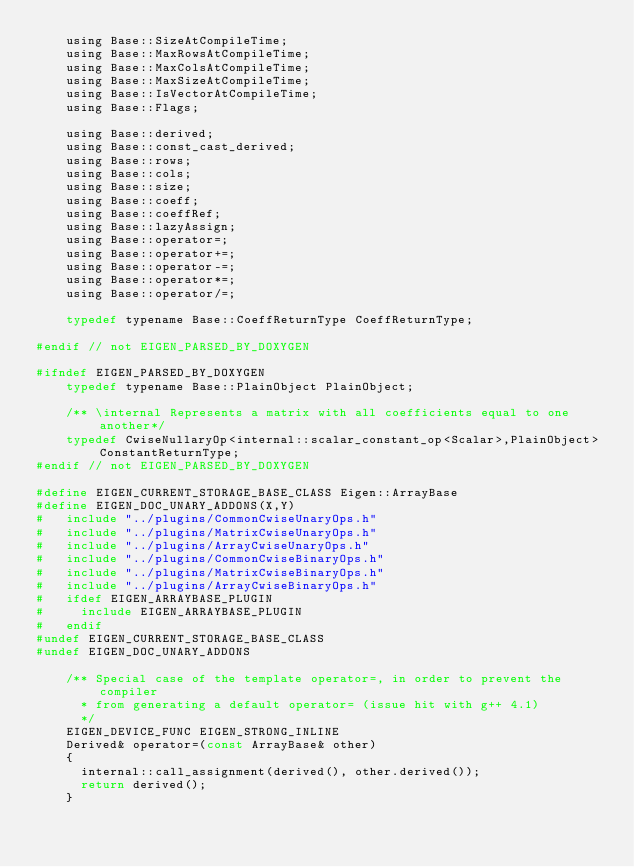Convert code to text. <code><loc_0><loc_0><loc_500><loc_500><_C_>    using Base::SizeAtCompileTime;
    using Base::MaxRowsAtCompileTime;
    using Base::MaxColsAtCompileTime;
    using Base::MaxSizeAtCompileTime;
    using Base::IsVectorAtCompileTime;
    using Base::Flags;
    
    using Base::derived;
    using Base::const_cast_derived;
    using Base::rows;
    using Base::cols;
    using Base::size;
    using Base::coeff;
    using Base::coeffRef;
    using Base::lazyAssign;
    using Base::operator=;
    using Base::operator+=;
    using Base::operator-=;
    using Base::operator*=;
    using Base::operator/=;

    typedef typename Base::CoeffReturnType CoeffReturnType;

#endif // not EIGEN_PARSED_BY_DOXYGEN

#ifndef EIGEN_PARSED_BY_DOXYGEN
    typedef typename Base::PlainObject PlainObject;

    /** \internal Represents a matrix with all coefficients equal to one another*/
    typedef CwiseNullaryOp<internal::scalar_constant_op<Scalar>,PlainObject> ConstantReturnType;
#endif // not EIGEN_PARSED_BY_DOXYGEN

#define EIGEN_CURRENT_STORAGE_BASE_CLASS Eigen::ArrayBase
#define EIGEN_DOC_UNARY_ADDONS(X,Y)
#   include "../plugins/CommonCwiseUnaryOps.h"
#   include "../plugins/MatrixCwiseUnaryOps.h"
#   include "../plugins/ArrayCwiseUnaryOps.h"
#   include "../plugins/CommonCwiseBinaryOps.h"
#   include "../plugins/MatrixCwiseBinaryOps.h"
#   include "../plugins/ArrayCwiseBinaryOps.h"
#   ifdef EIGEN_ARRAYBASE_PLUGIN
#     include EIGEN_ARRAYBASE_PLUGIN
#   endif
#undef EIGEN_CURRENT_STORAGE_BASE_CLASS
#undef EIGEN_DOC_UNARY_ADDONS

    /** Special case of the template operator=, in order to prevent the compiler
      * from generating a default operator= (issue hit with g++ 4.1)
      */
    EIGEN_DEVICE_FUNC EIGEN_STRONG_INLINE
    Derived& operator=(const ArrayBase& other)
    {
      internal::call_assignment(derived(), other.derived());
      return derived();
    }
    </code> 